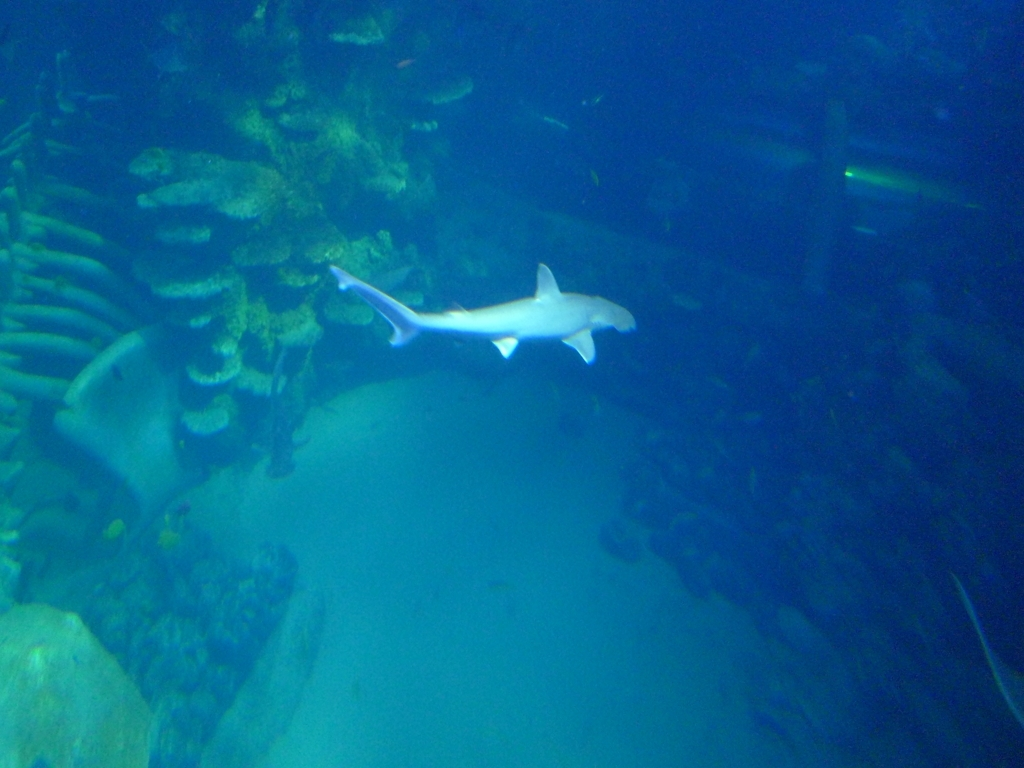Are many details difficult to identify in the image? While certain elements are visible, such as the shark and the underwater environment, the overall image has a bluish tint and lacks sharpness, making finer details less discernible. This could be due to the lighting conditions underwater and the nature of underwater photography. 